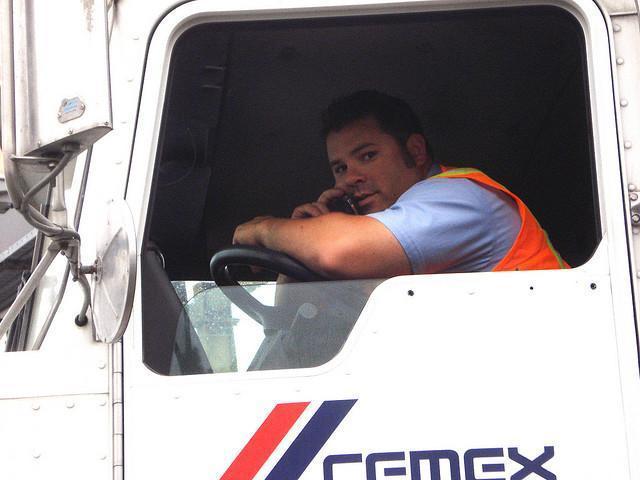How many white cars are on the road?
Give a very brief answer. 0. 